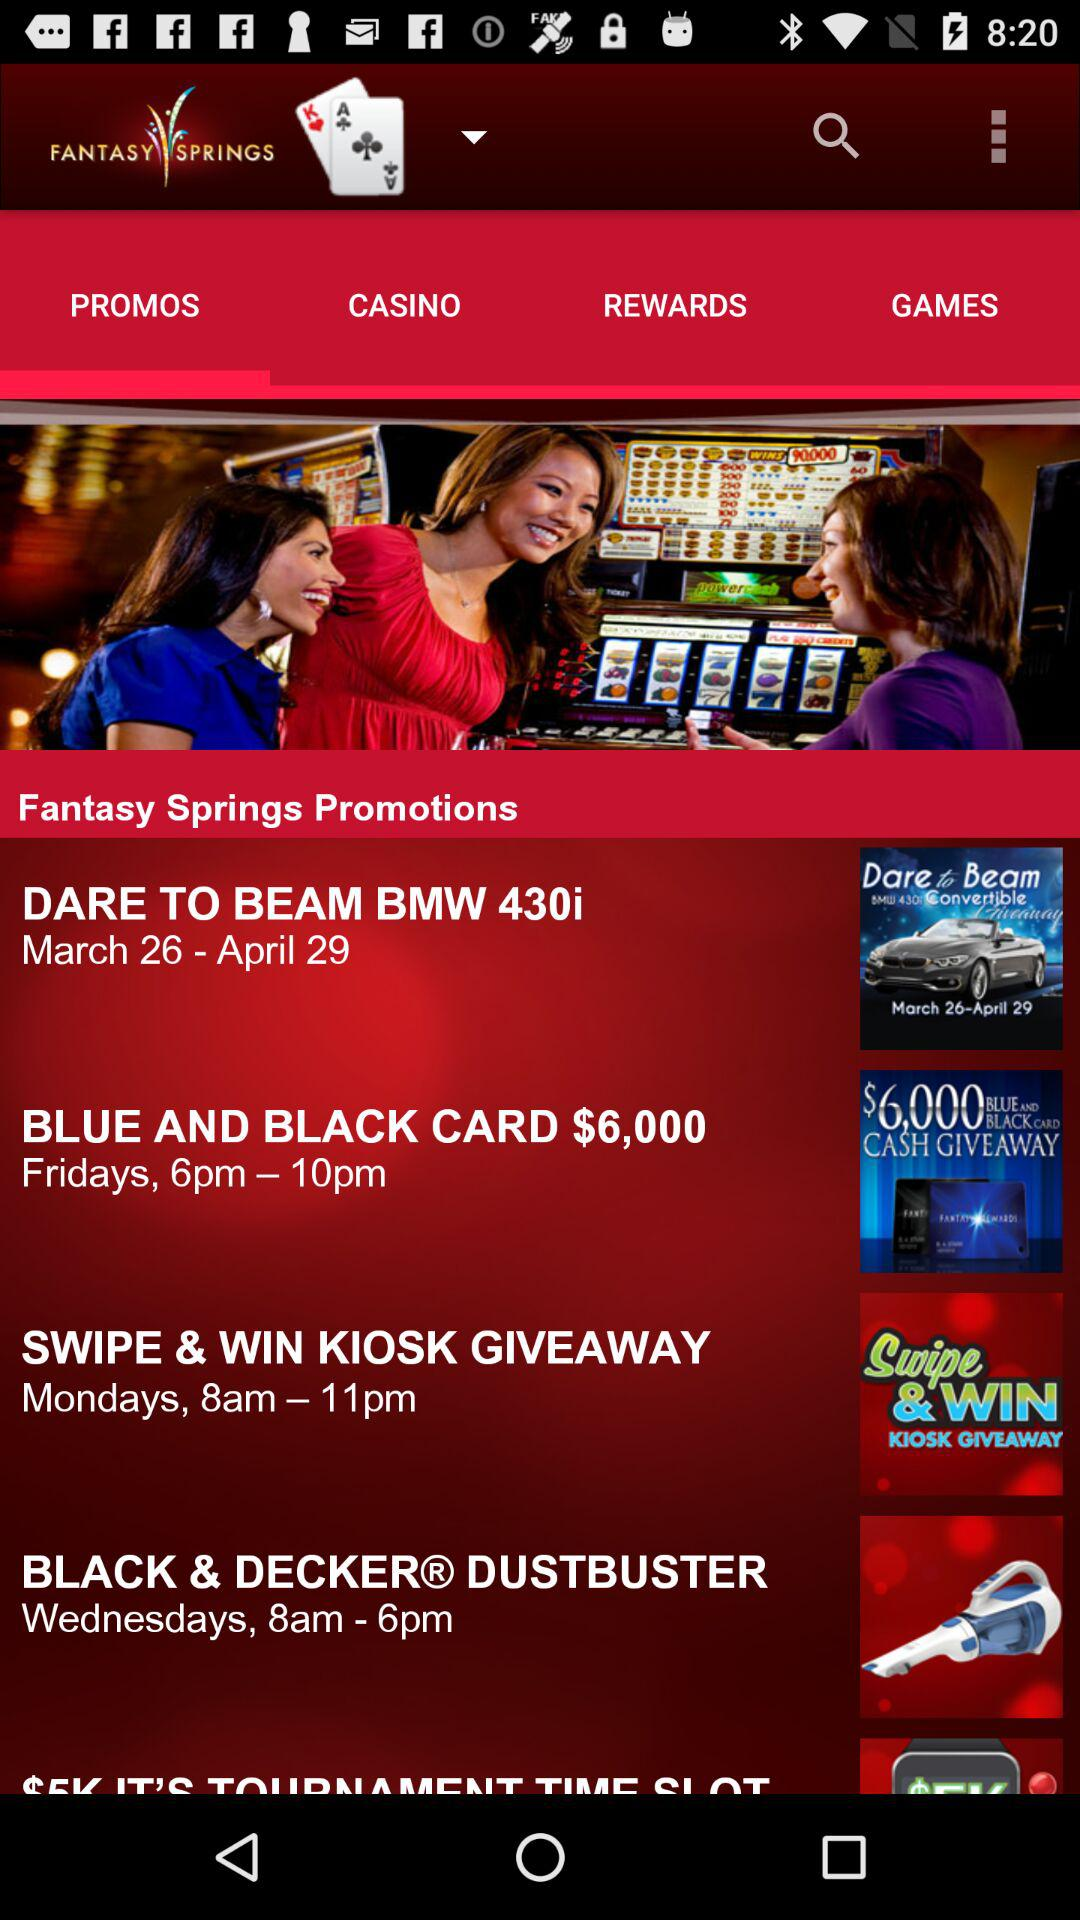From which date "DARE TO BEAM BMW 430i" will start? "DARE TO BEAM BMW 430i" will start from the date March 26. 